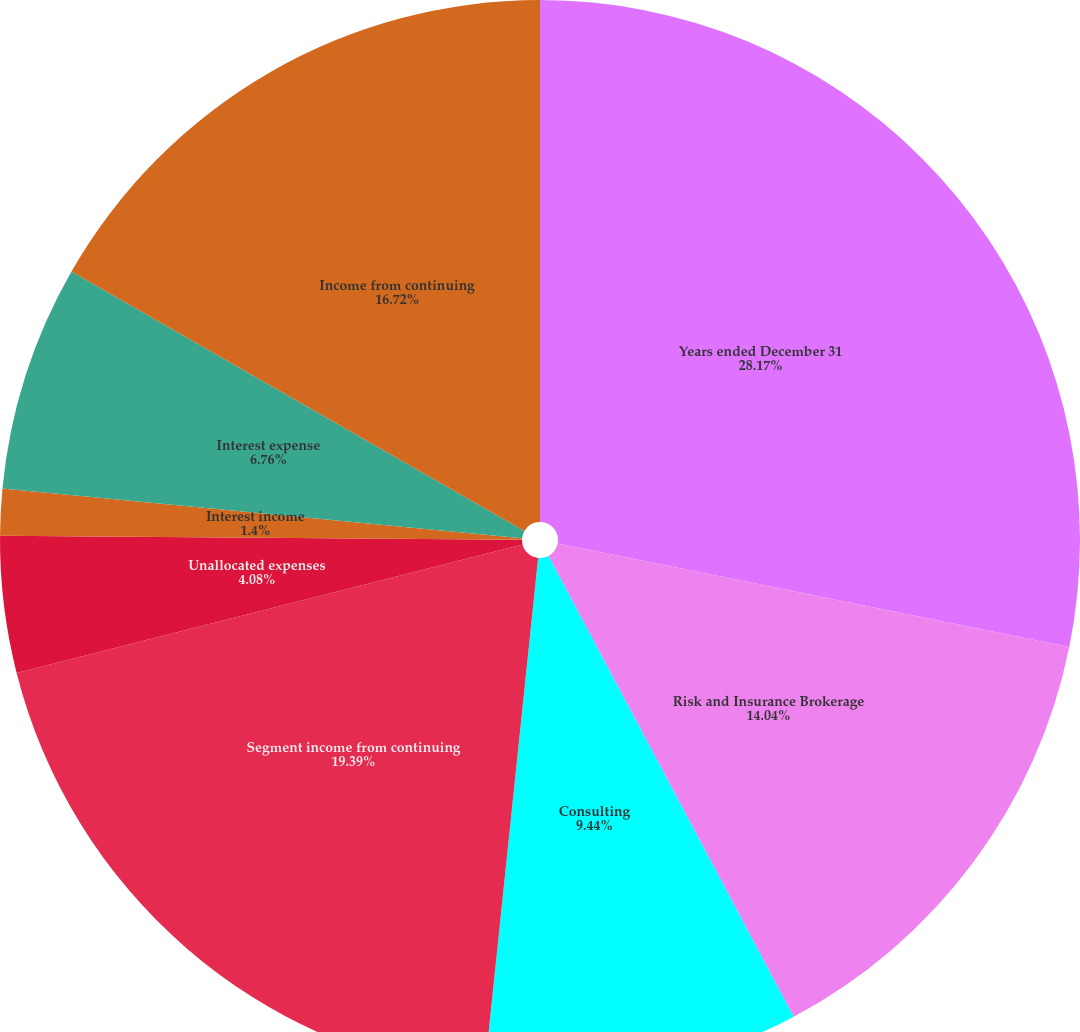Convert chart. <chart><loc_0><loc_0><loc_500><loc_500><pie_chart><fcel>Years ended December 31<fcel>Risk and Insurance Brokerage<fcel>Consulting<fcel>Segment income from continuing<fcel>Unallocated expenses<fcel>Interest income<fcel>Interest expense<fcel>Income from continuing<nl><fcel>28.18%<fcel>14.04%<fcel>9.44%<fcel>19.39%<fcel>4.08%<fcel>1.4%<fcel>6.76%<fcel>16.72%<nl></chart> 